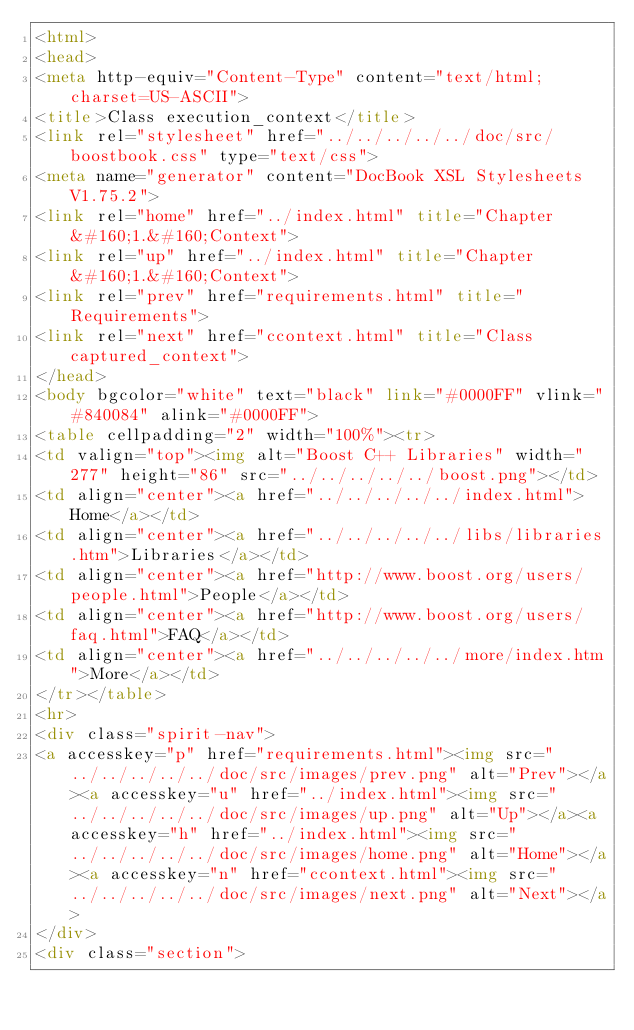<code> <loc_0><loc_0><loc_500><loc_500><_HTML_><html>
<head>
<meta http-equiv="Content-Type" content="text/html; charset=US-ASCII">
<title>Class execution_context</title>
<link rel="stylesheet" href="../../../../../doc/src/boostbook.css" type="text/css">
<meta name="generator" content="DocBook XSL Stylesheets V1.75.2">
<link rel="home" href="../index.html" title="Chapter&#160;1.&#160;Context">
<link rel="up" href="../index.html" title="Chapter&#160;1.&#160;Context">
<link rel="prev" href="requirements.html" title="Requirements">
<link rel="next" href="ccontext.html" title="Class captured_context">
</head>
<body bgcolor="white" text="black" link="#0000FF" vlink="#840084" alink="#0000FF">
<table cellpadding="2" width="100%"><tr>
<td valign="top"><img alt="Boost C++ Libraries" width="277" height="86" src="../../../../../boost.png"></td>
<td align="center"><a href="../../../../../index.html">Home</a></td>
<td align="center"><a href="../../../../../libs/libraries.htm">Libraries</a></td>
<td align="center"><a href="http://www.boost.org/users/people.html">People</a></td>
<td align="center"><a href="http://www.boost.org/users/faq.html">FAQ</a></td>
<td align="center"><a href="../../../../../more/index.htm">More</a></td>
</tr></table>
<hr>
<div class="spirit-nav">
<a accesskey="p" href="requirements.html"><img src="../../../../../doc/src/images/prev.png" alt="Prev"></a><a accesskey="u" href="../index.html"><img src="../../../../../doc/src/images/up.png" alt="Up"></a><a accesskey="h" href="../index.html"><img src="../../../../../doc/src/images/home.png" alt="Home"></a><a accesskey="n" href="ccontext.html"><img src="../../../../../doc/src/images/next.png" alt="Next"></a>
</div>
<div class="section"></code> 